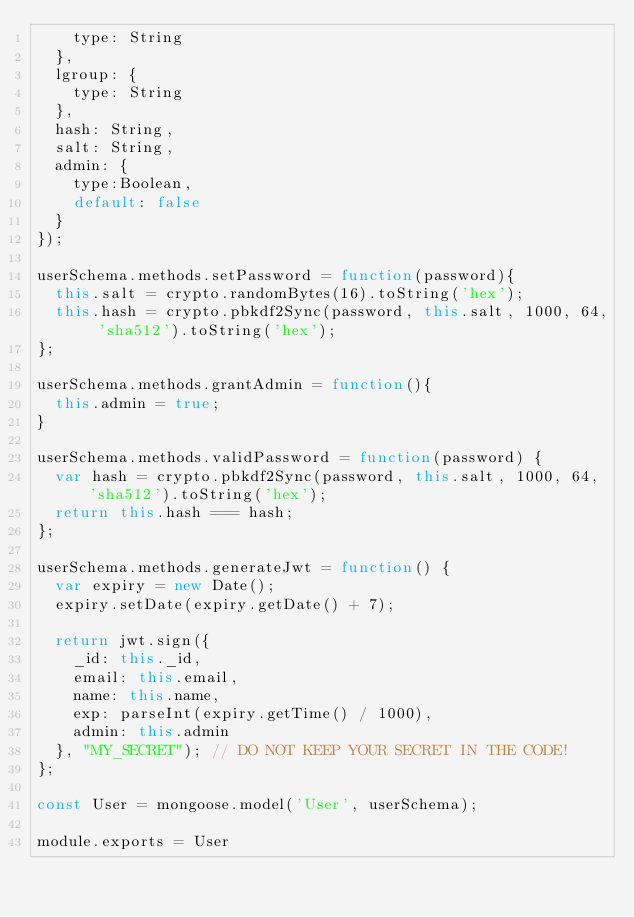Convert code to text. <code><loc_0><loc_0><loc_500><loc_500><_JavaScript_>    type: String
  },
  lgroup: {
    type: String
  },
  hash: String,
  salt: String,
  admin: {
    type:Boolean,
    default: false
  }
});

userSchema.methods.setPassword = function(password){
  this.salt = crypto.randomBytes(16).toString('hex');
  this.hash = crypto.pbkdf2Sync(password, this.salt, 1000, 64, 'sha512').toString('hex');
};

userSchema.methods.grantAdmin = function(){
  this.admin = true;
}

userSchema.methods.validPassword = function(password) {
  var hash = crypto.pbkdf2Sync(password, this.salt, 1000, 64, 'sha512').toString('hex');
  return this.hash === hash;
};

userSchema.methods.generateJwt = function() {
  var expiry = new Date();
  expiry.setDate(expiry.getDate() + 7);

  return jwt.sign({
    _id: this._id,
    email: this.email,
    name: this.name,
    exp: parseInt(expiry.getTime() / 1000),
    admin: this.admin
  }, "MY_SECRET"); // DO NOT KEEP YOUR SECRET IN THE CODE!
};

const User = mongoose.model('User', userSchema);

module.exports = User
</code> 